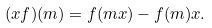<formula> <loc_0><loc_0><loc_500><loc_500>( x f ) ( m ) = f ( m x ) - f ( m ) x .</formula> 